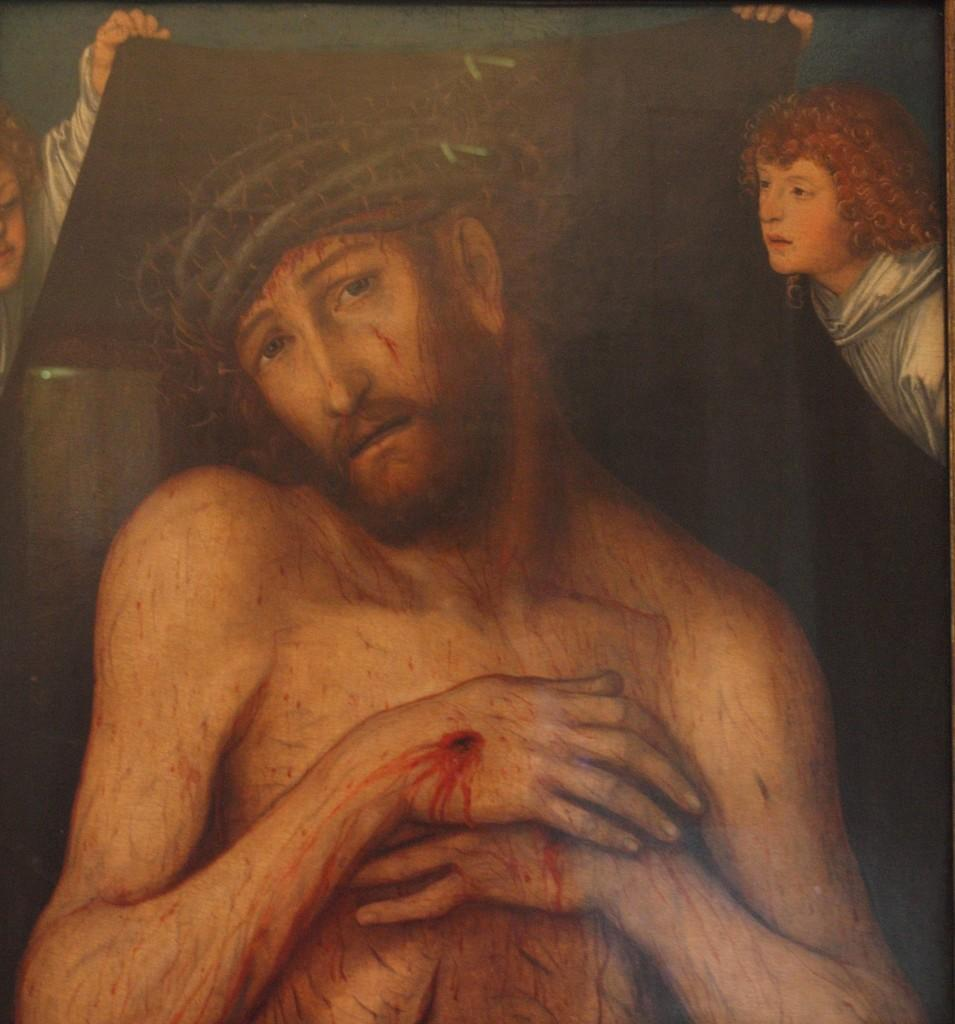What is depicted in the image? There is a painting of a man and two other persons in the image. What are the two other persons holding in the painting? The two other persons are holding an object in the painting. What type of guide is present in the image? There is no guide present in the image; it only contains paintings of three persons. 